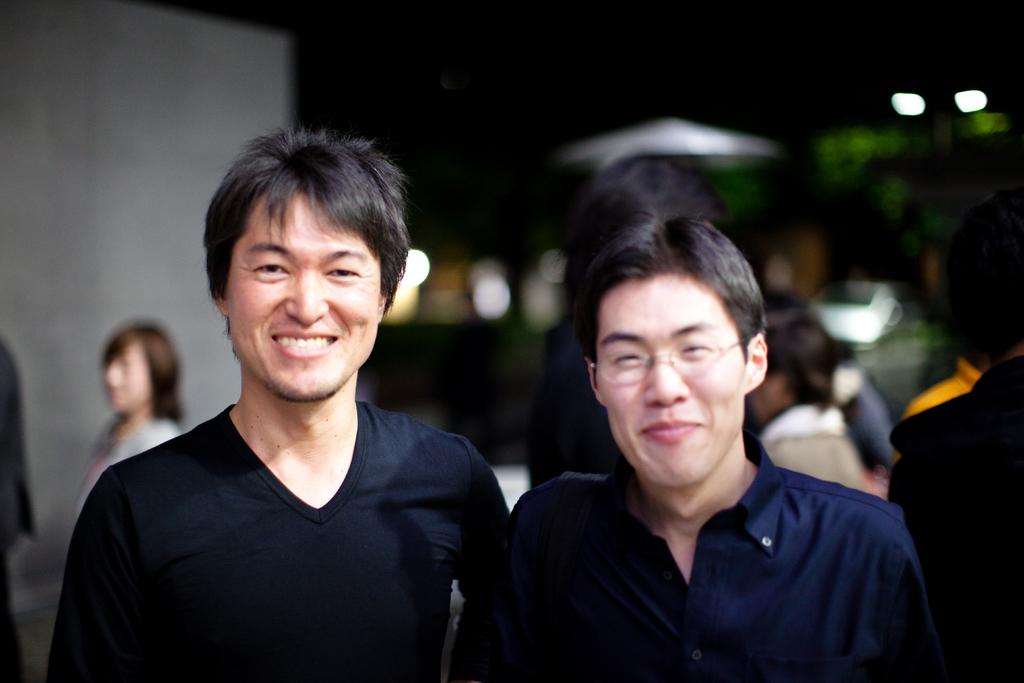Who can be seen in the middle of the image? There are two men in the middle of the image. What are the expressions on the faces of the two men? The two men are smiling. What else can be seen in the background of the image? There are people in the background of the image. Where are the lights located in the image? The lights are on the right side of the image. What type of zephyr can be seen blowing in the image? There is no zephyr present in the image; it is a term related to wind, and there is no indication of wind in the image. 